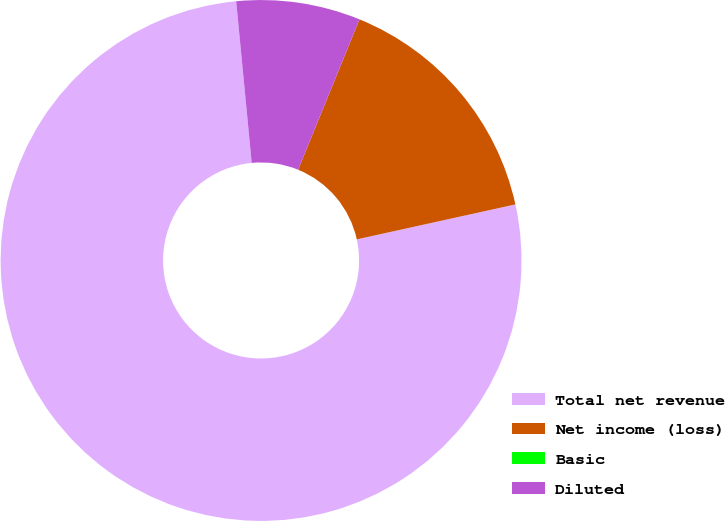Convert chart to OTSL. <chart><loc_0><loc_0><loc_500><loc_500><pie_chart><fcel>Total net revenue<fcel>Net income (loss)<fcel>Basic<fcel>Diluted<nl><fcel>76.92%<fcel>15.38%<fcel>0.0%<fcel>7.69%<nl></chart> 